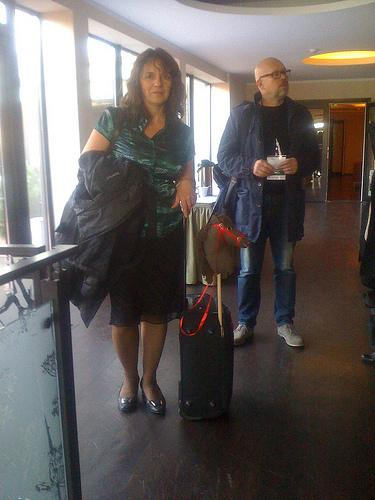State the most prominent subjects in the image, using adjectives. A bespectacled bald man, an elegantly dressed woman, a charming stick pony with a red ribbon, a practical black suitcase with wheels, and a gleaming silver plane flying in the sk.y Write a brief summary of the primary features in the image. A bald man with glasses, a woman in a green shirt and skirt, a stick pony with a red ribbon, a black suitcase, and a silver plane flying in the sky are the main features of the image. Write a simple, descriptive sentence about the main subjects in the image. A man wearing glasses and a woman with brown hair are seen near a stick pony and a black suitcase as a silver plane flies above. Provide a concise overview of the main subjects in the image. The image showcases a bald man with glasses, a woman in a green shirt, a stick pony with red ribbon, a black suitcase, and a flying silver plane. Enumerate five key elements found in the image. 5. Silver plane in the sky Create a sentence that summarizes the main objects and actions in the image. A bald man with glasses and a woman in a green shirt are in the foreground, with a stick pony with red ribbon, a black suitcase, and a silver plane flying above. Compose a short sentence including the main characters and objects present in the image. In the picture, a bald man with glasses and a woman in a green shirt stand near a stick pony, a black suitcase, and under a silver plane flying overhead. Mention the primary colors and items in the scene displayed in the image. The scene features a bald man in glasses, a woman in a green outfit, a black suitcase, a stick pony with a red ribbon, and a silver plane against a blue sky. Give a brief, creative description of the scene illustrated in the image. Amidst a colorful backdrop, a savvy bald man with glasses and a stylish woman in green find themselves in the company of a spirited stick pony, a trusty black suitcase, and a majestic silver plane soaring above. Provide a narrative description of the scene in the image. In the image, a woman wearing a green shirt and a skirt is accompanied by a bald man with glasses. Nearby, a stick pony with red ribbon and a black suitcase can be seen, while a silver plane flies above in the sky. 